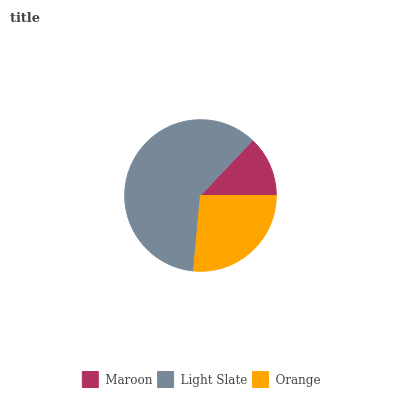Is Maroon the minimum?
Answer yes or no. Yes. Is Light Slate the maximum?
Answer yes or no. Yes. Is Orange the minimum?
Answer yes or no. No. Is Orange the maximum?
Answer yes or no. No. Is Light Slate greater than Orange?
Answer yes or no. Yes. Is Orange less than Light Slate?
Answer yes or no. Yes. Is Orange greater than Light Slate?
Answer yes or no. No. Is Light Slate less than Orange?
Answer yes or no. No. Is Orange the high median?
Answer yes or no. Yes. Is Orange the low median?
Answer yes or no. Yes. Is Light Slate the high median?
Answer yes or no. No. Is Light Slate the low median?
Answer yes or no. No. 